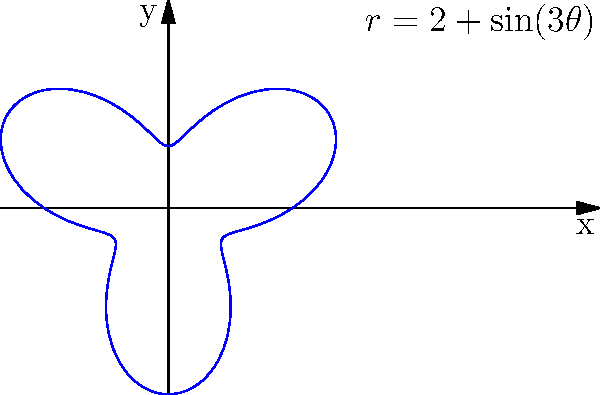As a knife designer, you're developing a new locking mechanism for a folding knife. The shape of this mechanism can be described in polar coordinates by the equation $r = 2 + \sin(3\theta)$. What is the maximum radial distance of this shape from the origin, and at what angle(s) does it occur? To find the maximum radial distance and the corresponding angle(s), we need to follow these steps:

1) The radial distance is given by $r = 2 + \sin(3\theta)$.

2) The maximum value of sine is 1, which occurs when its argument is $\frac{\pi}{2}$ or odd multiples of it.

3) So, we need to solve: $3\theta = \frac{\pi}{2} + 2\pi n$, where $n$ is an integer.

4) Solving for $\theta$:
   $\theta = \frac{\pi}{6} + \frac{2\pi n}{3}$

5) The first solution (when $n=0$) is $\theta = \frac{\pi}{6}$.

6) The maximum radial distance occurs when $\sin(3\theta) = 1$:
   $r_{max} = 2 + 1 = 3$

7) This maximum occurs at angles:
   $\theta = \frac{\pi}{6}, \frac{5\pi}{6}, \frac{3\pi}{2}$

Therefore, the maximum radial distance is 3 units, occurring at angles $\frac{\pi}{6}$, $\frac{5\pi}{6}$, and $\frac{3\pi}{2}$ radians.
Answer: Maximum radial distance: 3 units; Angles: $\frac{\pi}{6}$, $\frac{5\pi}{6}$, $\frac{3\pi}{2}$ radians 